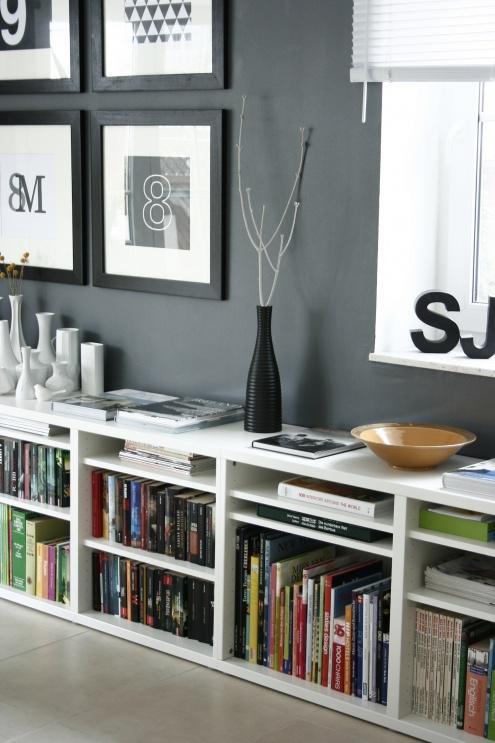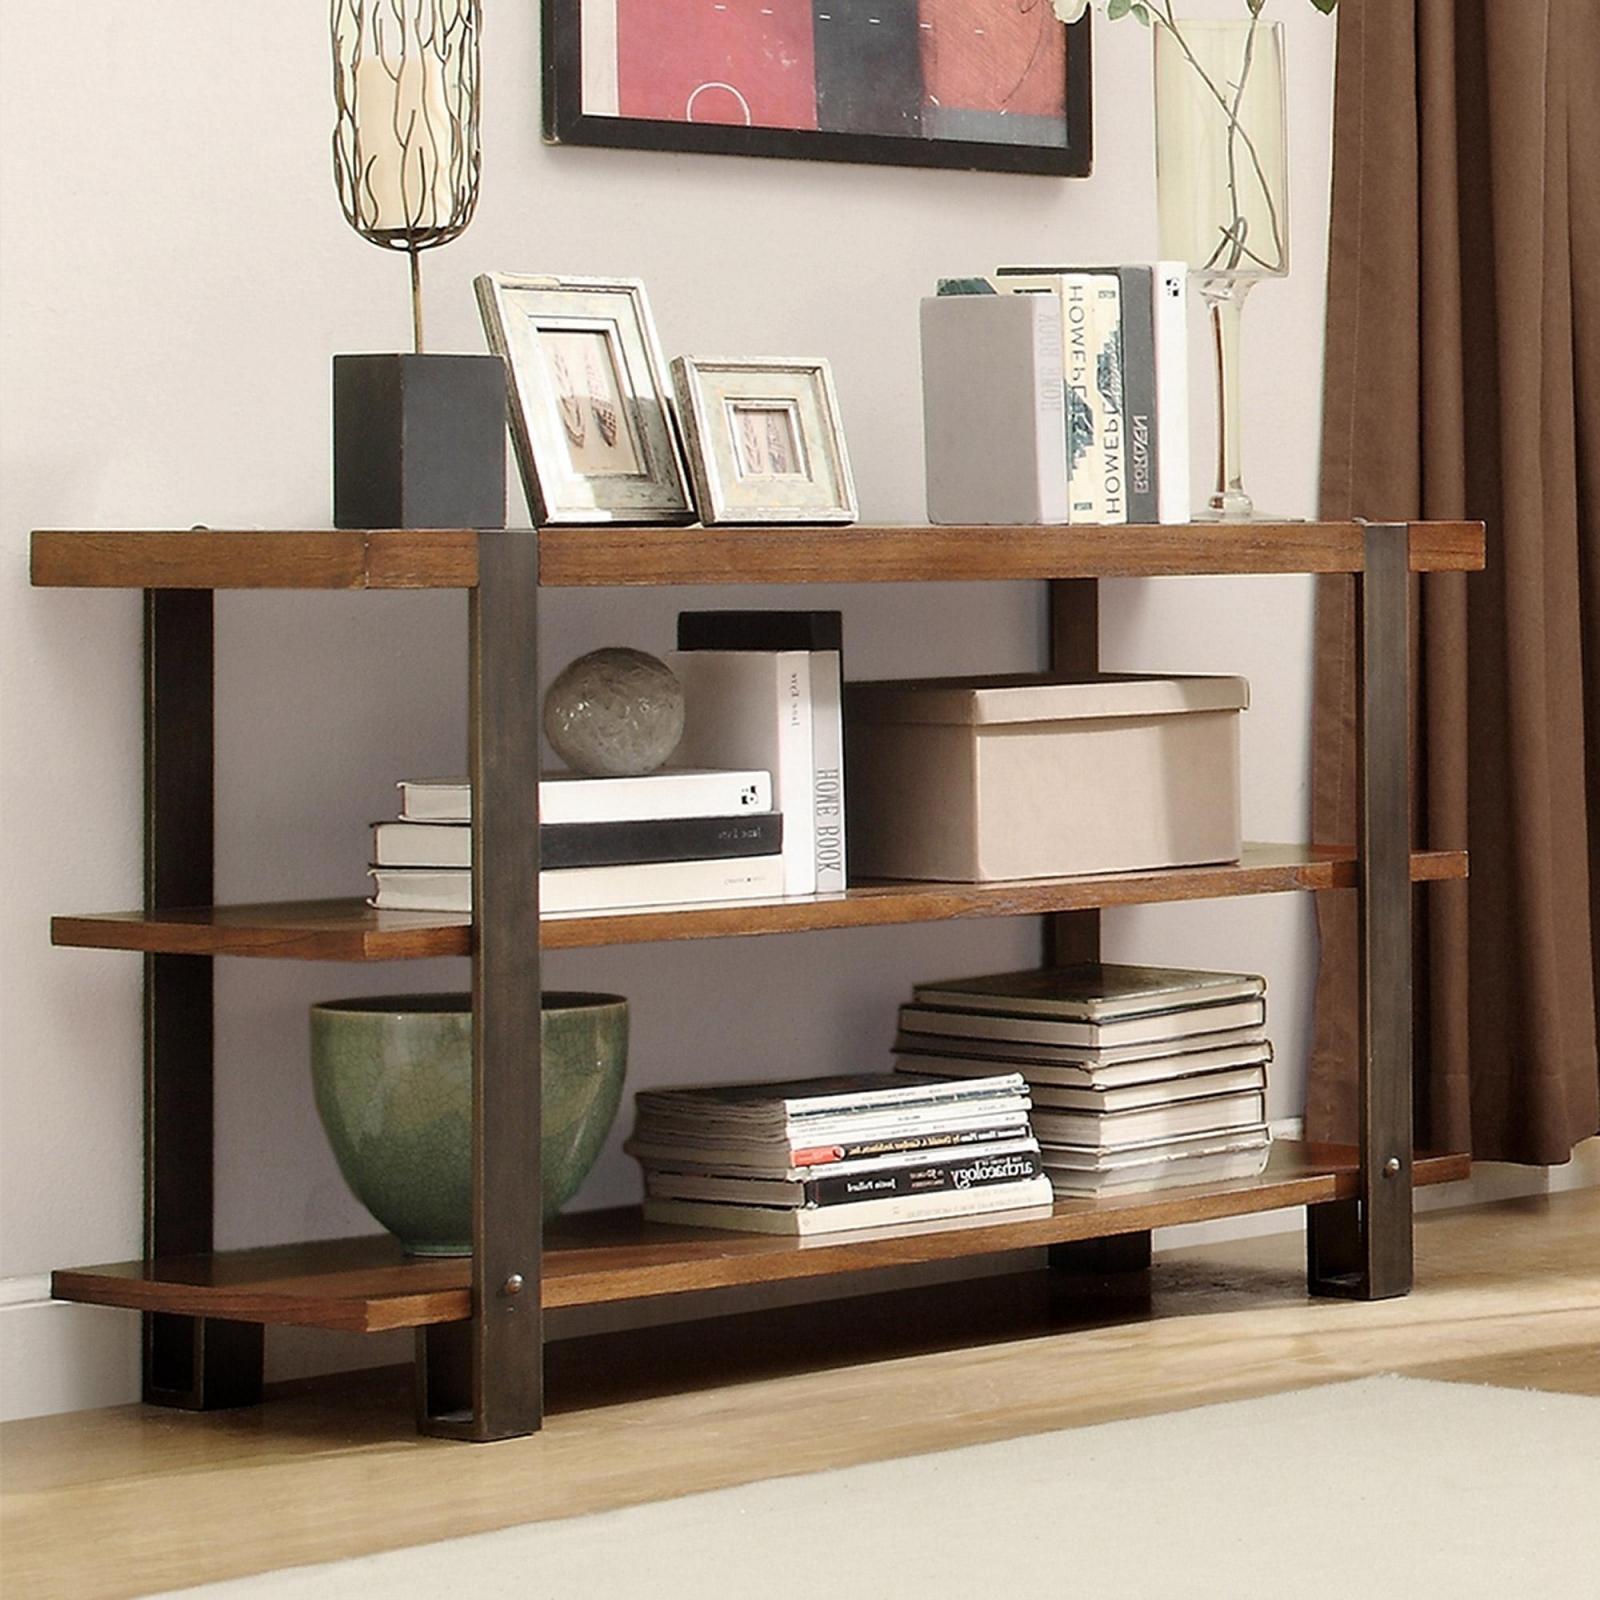The first image is the image on the left, the second image is the image on the right. For the images shown, is this caption "Each shelving unit is wider than it is tall and has exactly two shelf levels, but one sits flush on the floor and the other has short legs." true? Answer yes or no. No. 